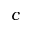Convert formula to latex. <formula><loc_0><loc_0><loc_500><loc_500>c</formula> 